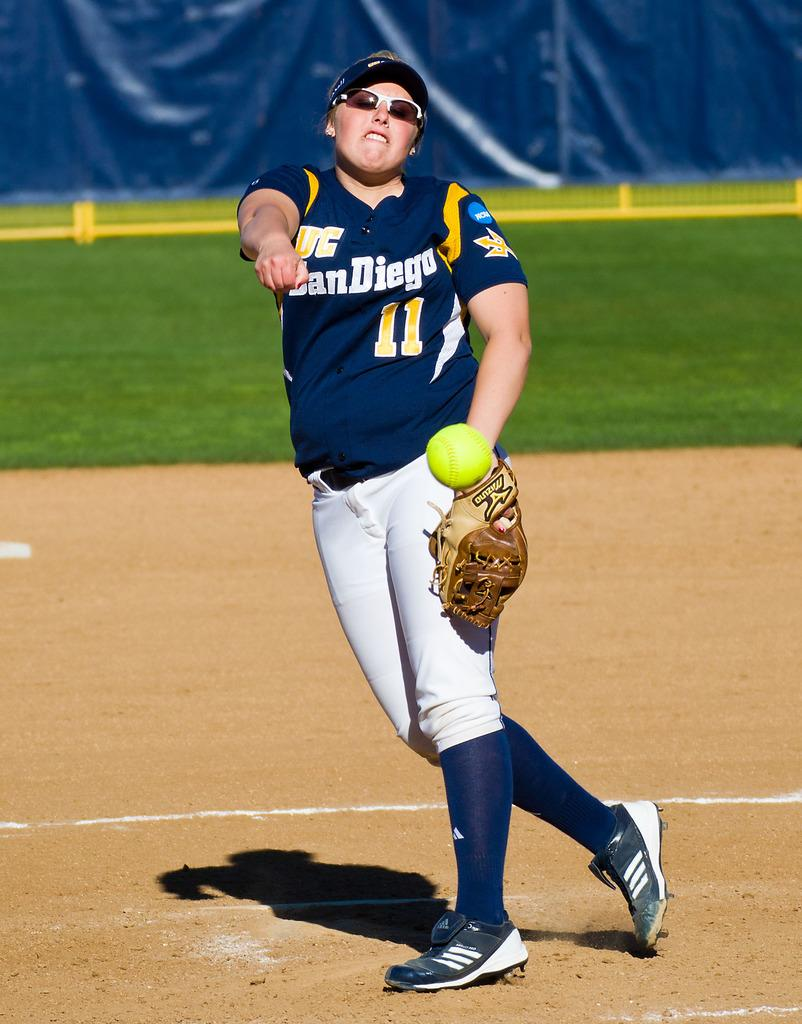<image>
Present a compact description of the photo's key features. A baseball player wearing a San Diego number 11 jersey. 